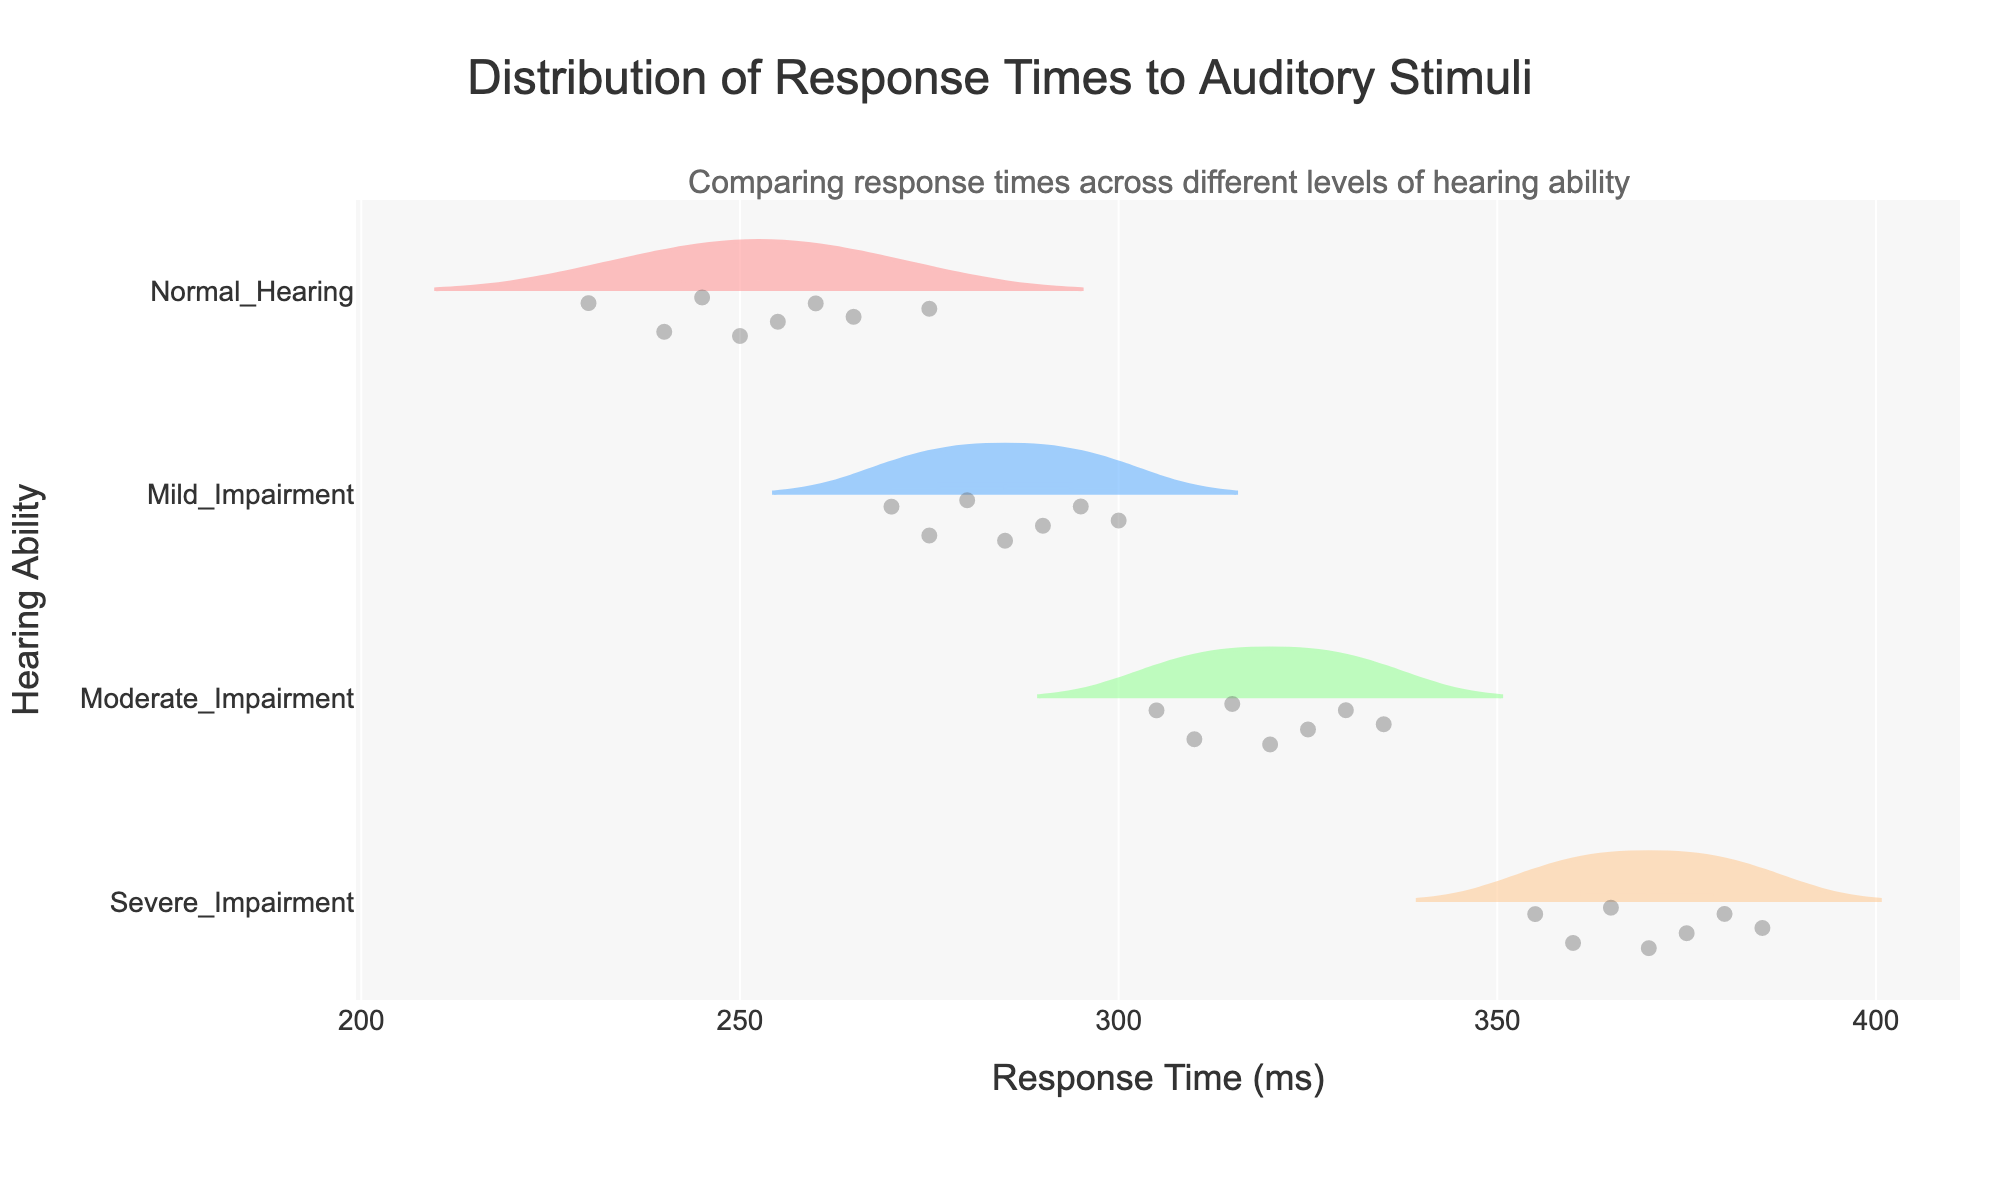What is the title of the figure? The title is typically located at the top of the figure. It succinctly states the main topic the figure is addressing.
Answer: Distribution of Response Times to Auditory Stimuli Which group shows the highest response times on average? To determine the group with the highest response times on average, examine the mean line in each violin plot and see which category it falls at the highest point along the x-axis.
Answer: Severe_Impairment How many different levels of hearing ability are represented in the figure? The levels of hearing ability are shown along the y-axis. Count the distinct categories listed.
Answer: 4 What is the range of response times for those with moderate impairment? Observe the spread of the data points in the Moderate_Impairment category's violin plot. The range is identified as the distance between the lowest and highest points.
Answer: 305-335 ms Which group has the most varied response times? The most varied response times will show the widest violin plot, indicating a greater spread of data points.
Answer: Severe_Impairment What characteristic does the color and shading indicate? The color and shading are used to differentiate between the categories, making it easier to distinguish the data sets for each hearing ability.
Answer: Differentiation of categories Is the data for each hearing ability group symmetrical? Check the shape of the violin plots. Symmetrical data will have a balanced appearance on either side of the center line.
Answer: No Which hearing ability group has the smallest median response time? The median is typically shown as a line within the violin plot. Identify the group whose median line is the furthest left on the x-axis.
Answer: Normal_Hearing How can you tell the distribution shape of response times for mild impairment? Look at the violin plot for Mild_Impairment. The shape and density indicate the distribution, with wider areas representing more data points at those response times.
Answer: Right-skewed Are there any outliers in the Normal_Hearing response times? Outliers are identified by points that fall significantly outside the main body of the violin plot. Check for any such points in the Normal_Hearing category.
Answer: No 